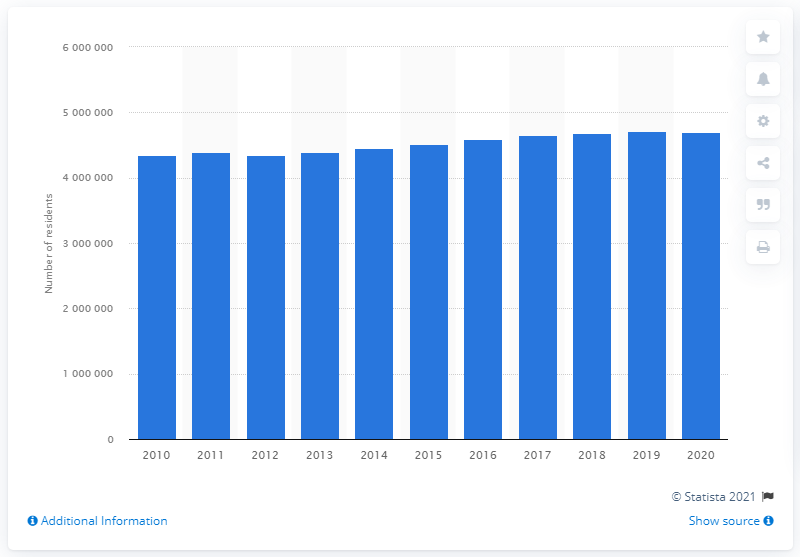Outline some significant characteristics in this image. The population of the San Francisco-Oakland-Berkeley metropolitan area in 2020 was approximately 4648164. In the previous year, the population of the San Francisco-Oakland-Berkeley metropolitan area was approximately 4688017 people. 